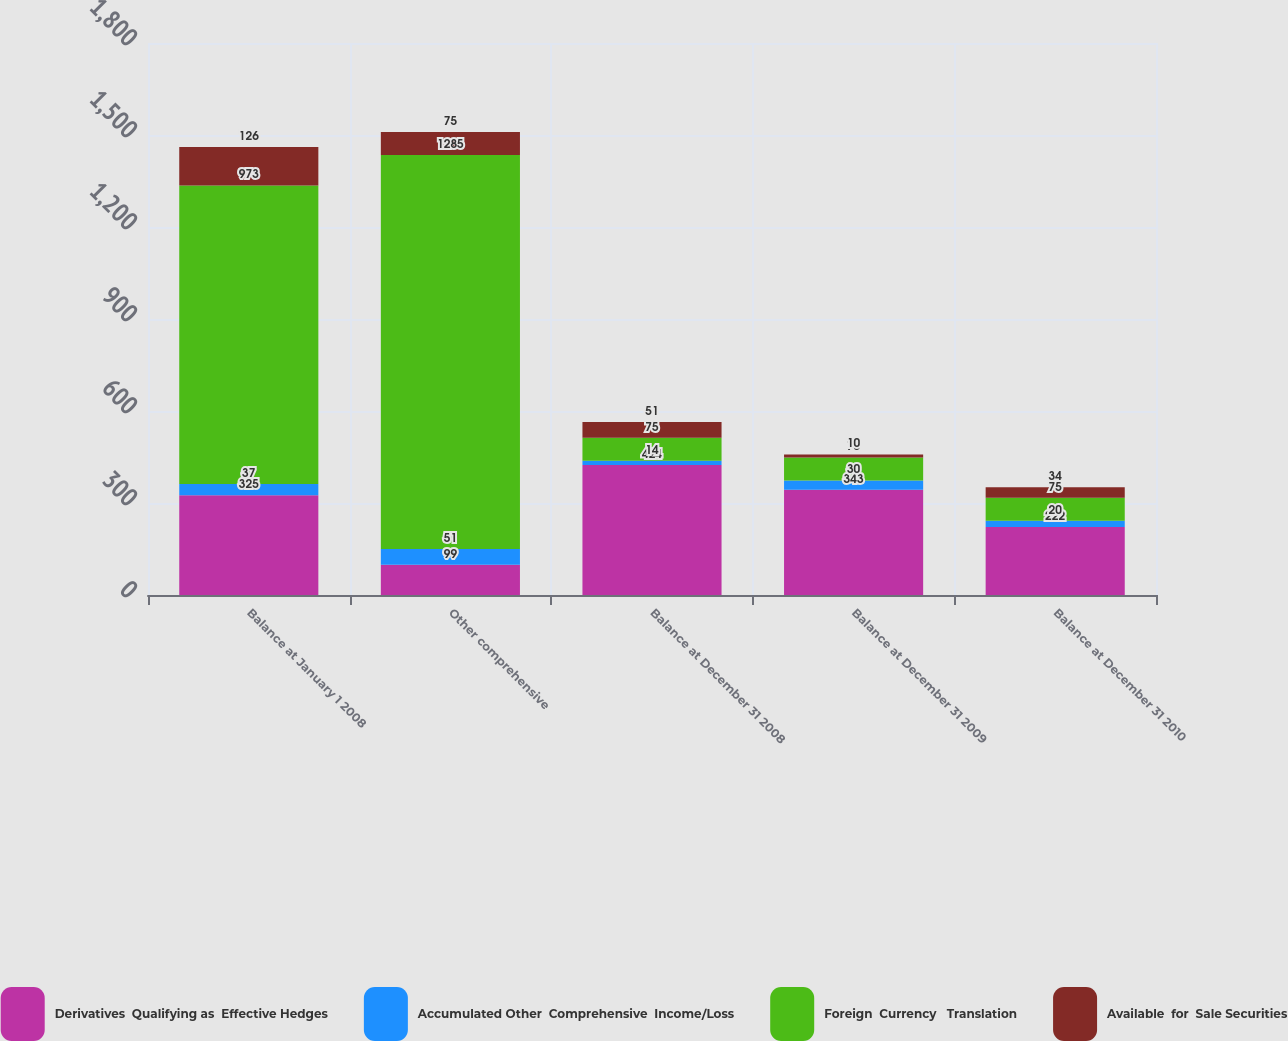<chart> <loc_0><loc_0><loc_500><loc_500><stacked_bar_chart><ecel><fcel>Balance at January 1 2008<fcel>Other comprehensive<fcel>Balance at December 31 2008<fcel>Balance at December 31 2009<fcel>Balance at December 31 2010<nl><fcel>Derivatives  Qualifying as  Effective Hedges<fcel>325<fcel>99<fcel>424<fcel>343<fcel>222<nl><fcel>Accumulated Other  Comprehensive  Income/Loss<fcel>37<fcel>51<fcel>14<fcel>30<fcel>20<nl><fcel>Foreign  Currency   Translation<fcel>973<fcel>1285<fcel>75<fcel>75<fcel>75<nl><fcel>Available  for  Sale Securities<fcel>126<fcel>75<fcel>51<fcel>10<fcel>34<nl></chart> 